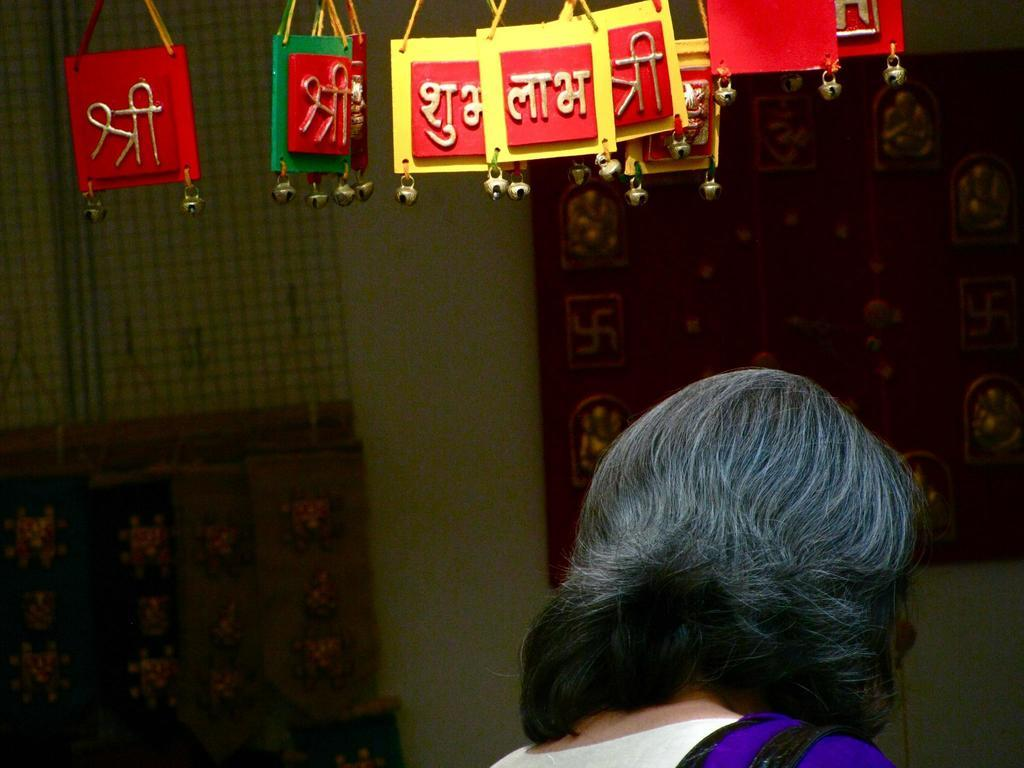Who is present at the bottom of the image? There is a lady at the bottom of the image. What can be seen in the background of the image? There is a wall in the background of the image. What type of objects are at the top of the image? There are decorative objects at the top of the image. What type of rail is present in the image? There is no rail present in the image. What color is the collar on the lady in the image? The provided facts do not mention a collar on the lady, so we cannot determine the color of a collar. 